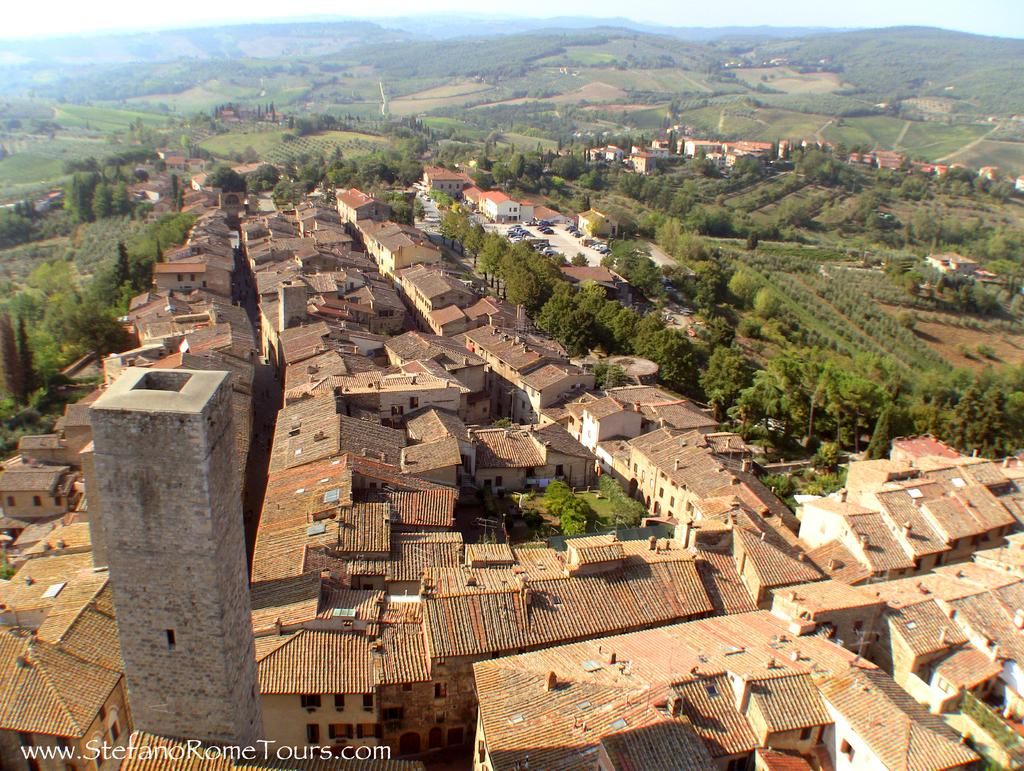What types of structures are visible in the image? There are multiple buildings in the image. What other natural elements can be seen in the image? There are trees and hills in the image. What type of pen is being used to draw the plants in the image? There are no plants or pens present in the image; it features multiple buildings, trees, and hills. 